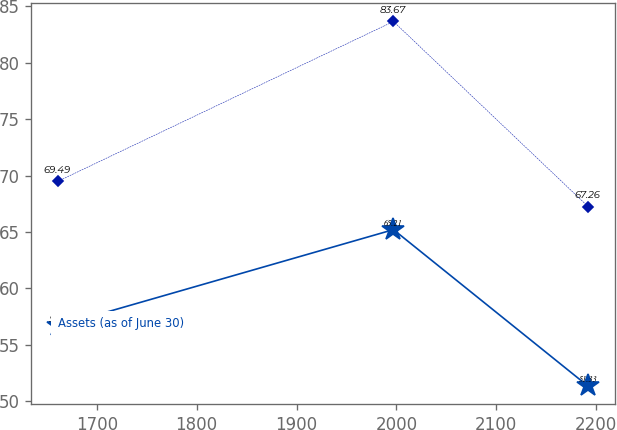Convert chart to OTSL. <chart><loc_0><loc_0><loc_500><loc_500><line_chart><ecel><fcel>Unnamed: 1<fcel>Assets (as of June 30)<nl><fcel>1660.97<fcel>69.49<fcel>56.65<nl><fcel>1997.04<fcel>83.67<fcel>65.21<nl><fcel>2191.82<fcel>67.26<fcel>51.33<nl></chart> 